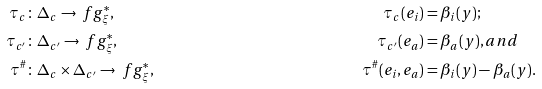Convert formula to latex. <formula><loc_0><loc_0><loc_500><loc_500>\tau _ { c } \colon \, & \Delta _ { c } \to \ f g _ { \xi } ^ { * } , & \tau _ { c } ( e _ { i } ) & = \beta _ { i } ( y ) ; \\ \tau _ { c ^ { \prime } } \colon \, & \Delta _ { c ^ { \prime } } \to \ f g _ { \xi } ^ { * } , & \tau _ { c ^ { \prime } } ( e _ { a } ) & = \beta _ { a } ( y ) , a n d \\ \tau ^ { \# } \colon \, & \Delta _ { c } \times \Delta _ { c ^ { \prime } } \to \ f g _ { \xi } ^ { * } , & \tau ^ { \# } ( e _ { i } , e _ { a } ) & = \beta _ { i } ( y ) - \beta _ { a } ( y ) .</formula> 